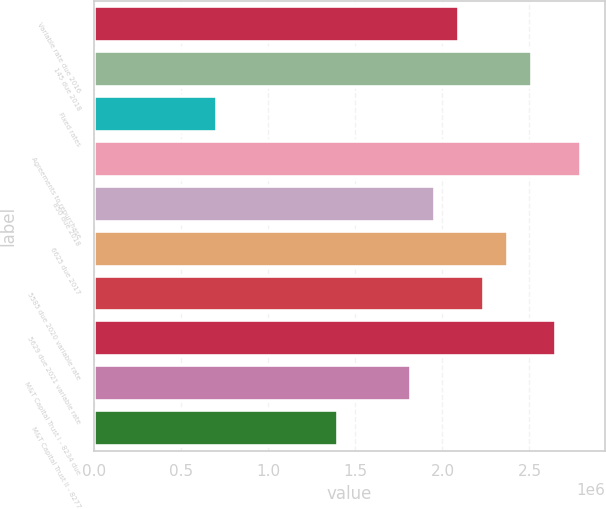Convert chart. <chart><loc_0><loc_0><loc_500><loc_500><bar_chart><fcel>Variable rate due 2016<fcel>145 due 2018<fcel>Fixed rates<fcel>Agreements to repurchase<fcel>850 due 2018<fcel>6625 due 2017<fcel>5585 due 2020 variable rate<fcel>5629 due 2021 variable rate<fcel>M&T Capital Trust I - 8234 due<fcel>M&T Capital Trust II - 8277<nl><fcel>2.09674e+06<fcel>2.51478e+06<fcel>703260<fcel>2.79348e+06<fcel>1.95739e+06<fcel>2.37544e+06<fcel>2.23609e+06<fcel>2.65413e+06<fcel>1.81804e+06<fcel>1.4e+06<nl></chart> 